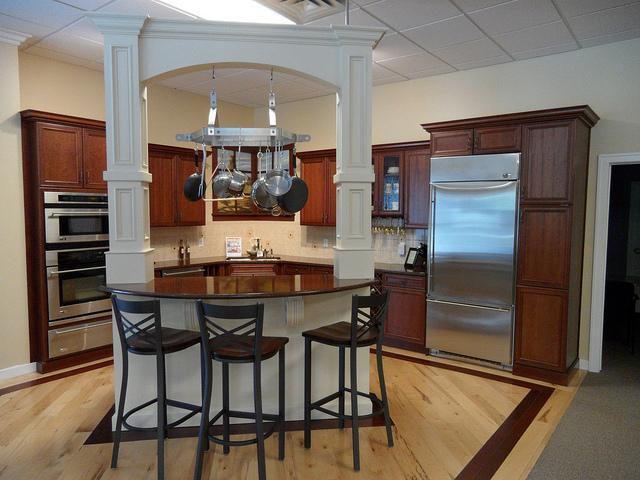How many chairs are there?
Give a very brief answer. 3. How many chairs are shown?
Give a very brief answer. 3. How many chairs are in the picture?
Give a very brief answer. 3. How many dining tables are in the photo?
Give a very brief answer. 1. How many people are wearing red?
Give a very brief answer. 0. 